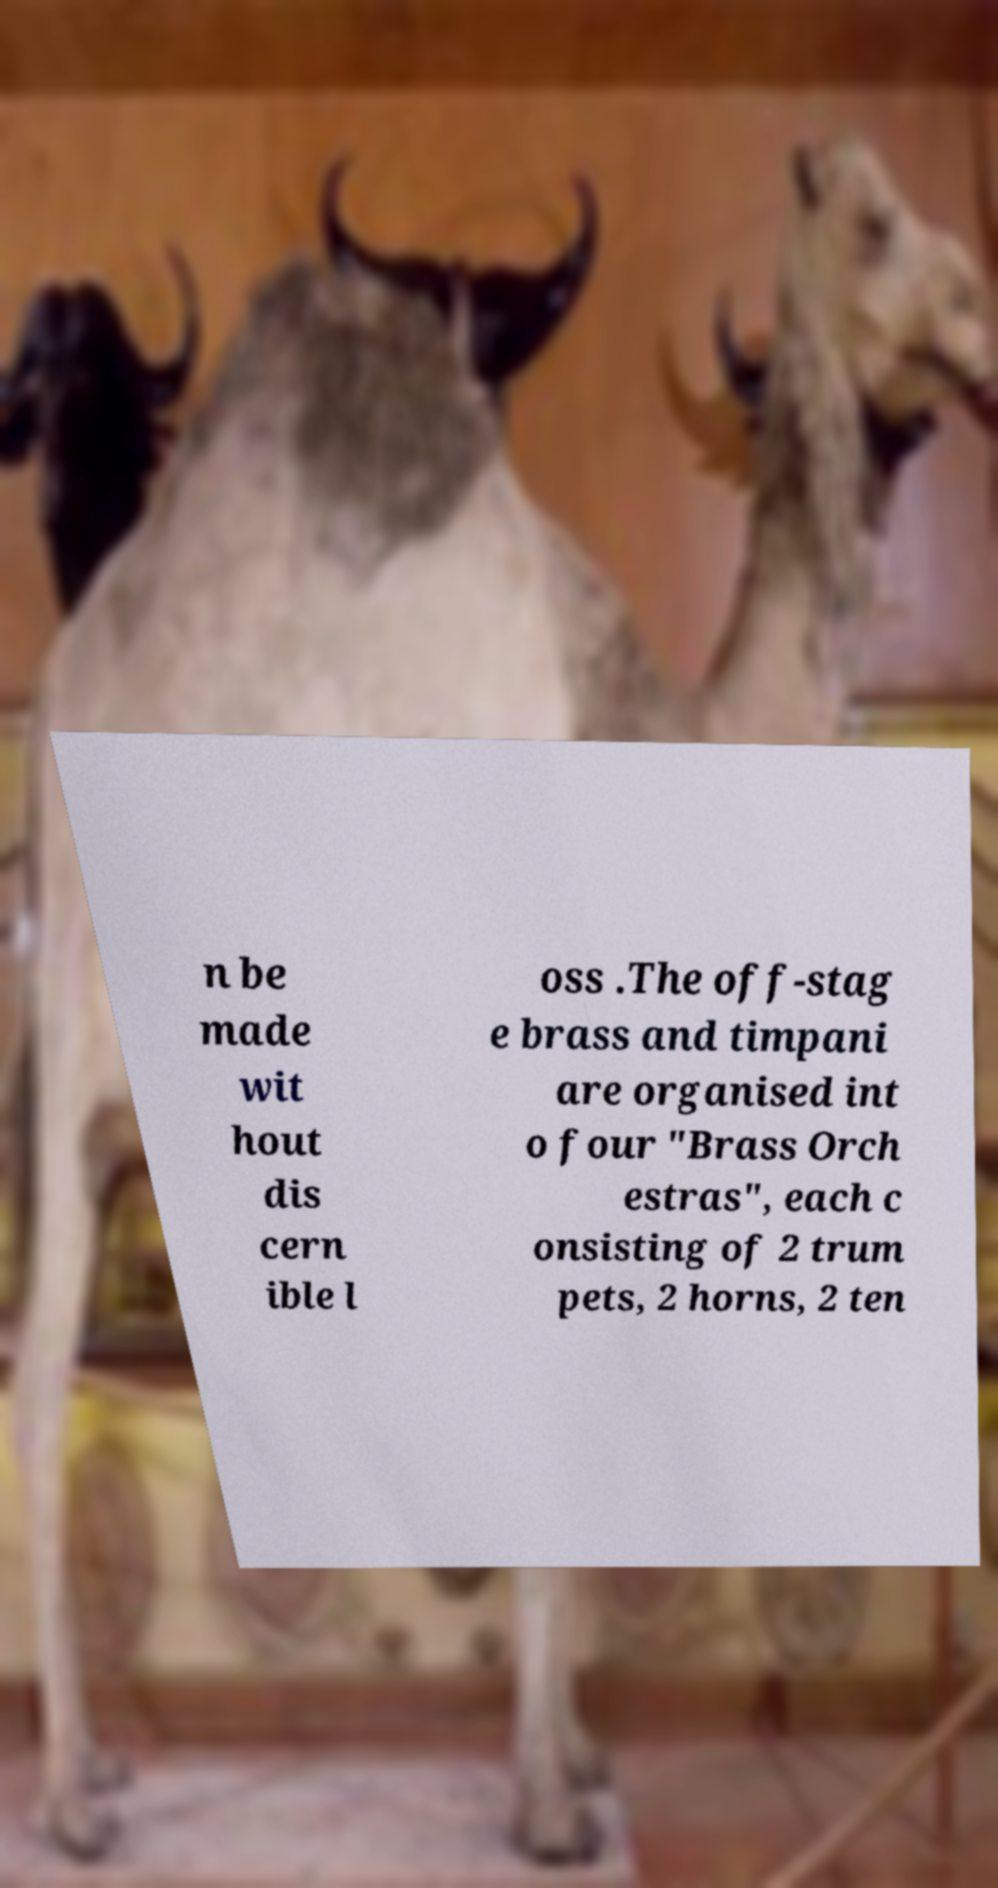What messages or text are displayed in this image? I need them in a readable, typed format. n be made wit hout dis cern ible l oss .The off-stag e brass and timpani are organised int o four "Brass Orch estras", each c onsisting of 2 trum pets, 2 horns, 2 ten 